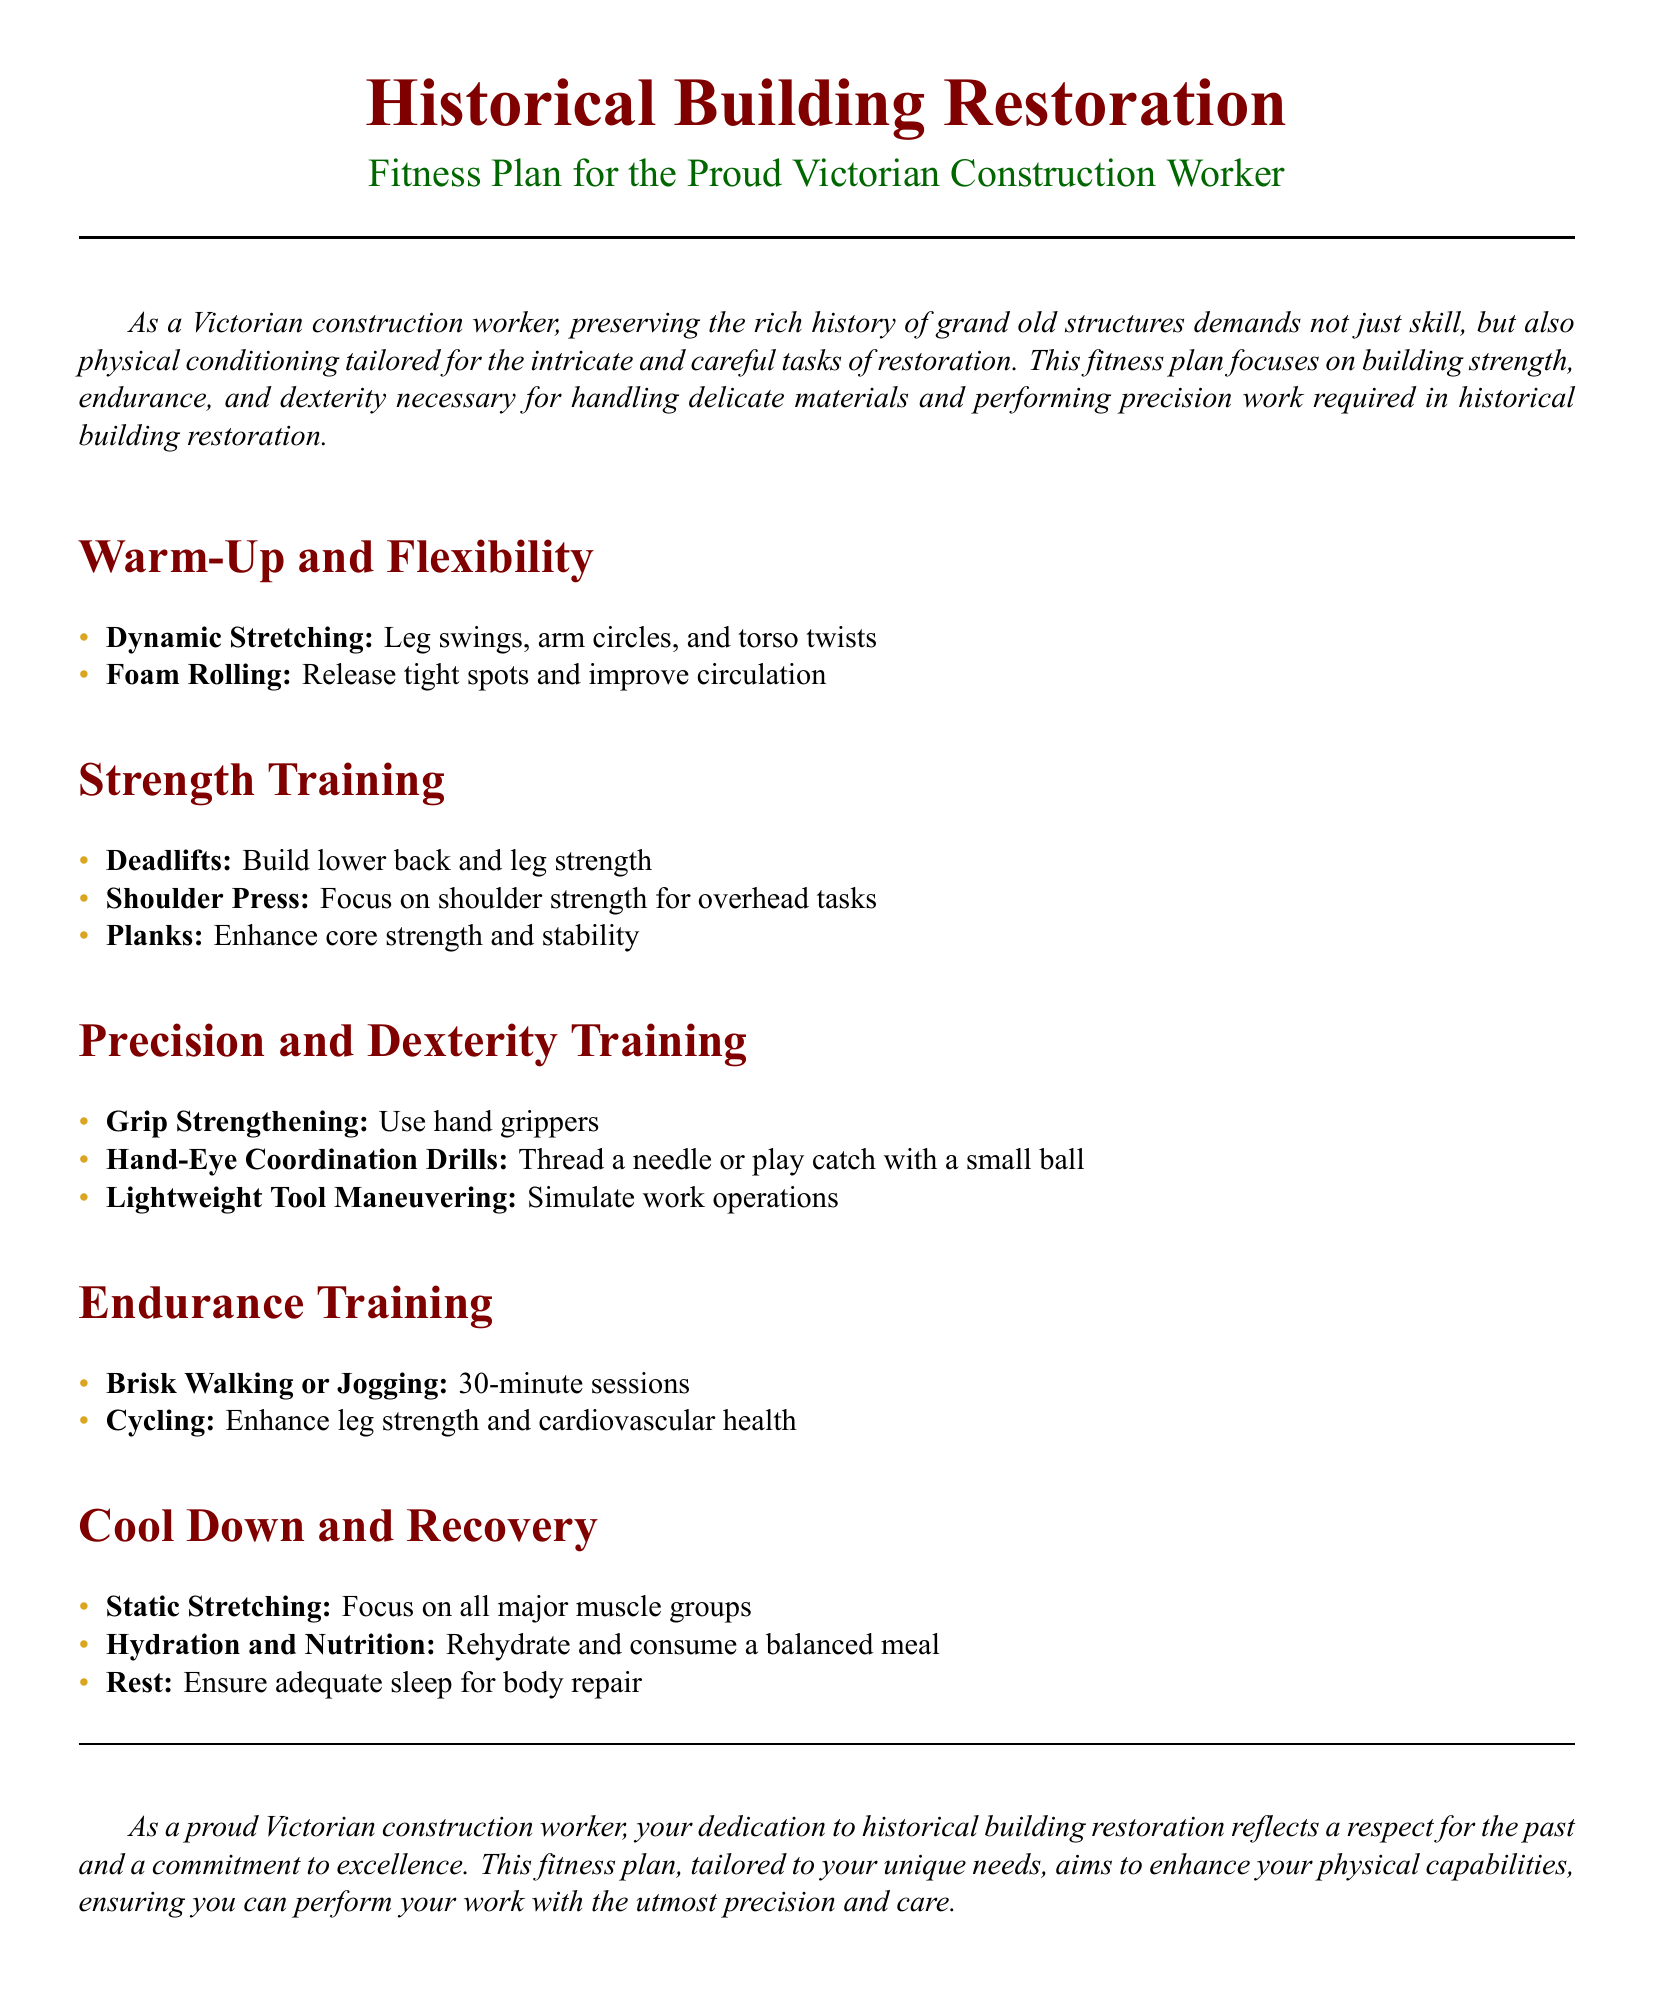What is the title of the document? The title is prominently displayed at the top of the document and is "Historical Building Restoration".
Answer: Historical Building Restoration What fitness plan is designed for? The fitness plan is specifically created for a target audience outlined in the document, which is highlighted in the subtitle.
Answer: Proud Victorian Construction Worker How many exercises are listed under Strength Training? The number of exercises can be counted from the section titled Strength Training.
Answer: Three What type of drills are suggested for Precision and Dexterity Training? The document specifies types of training drills designed to enhance a specific skill set.
Answer: Hand-Eye Coordination Drills What is the first exercise in the Warm-Up and Flexibility section? The sequence of exercises in this section provides a clear structure to this fitness plan, indicating the first activity.
Answer: Dynamic Stretching How long should the brisk walking or jogging sessions last? The duration is stated in the Endurance Training section following the exercise instruction.
Answer: 30-minute sessions What is recommended to focus on during the Cool Down and Recovery phase? The document mentions specific activities to engage in after workouts to ensure recovery.
Answer: All major muscle groups What is emphasized for hydration and nutrition after exercise? This aspect is outlined in the Cool Down and Recovery section regarding post-workout care.
Answer: Rehydrate and consume a balanced meal Which exercise helps build lower back and leg strength? The exercise is identified within the Strength Training section of the document.
Answer: Deadlifts 